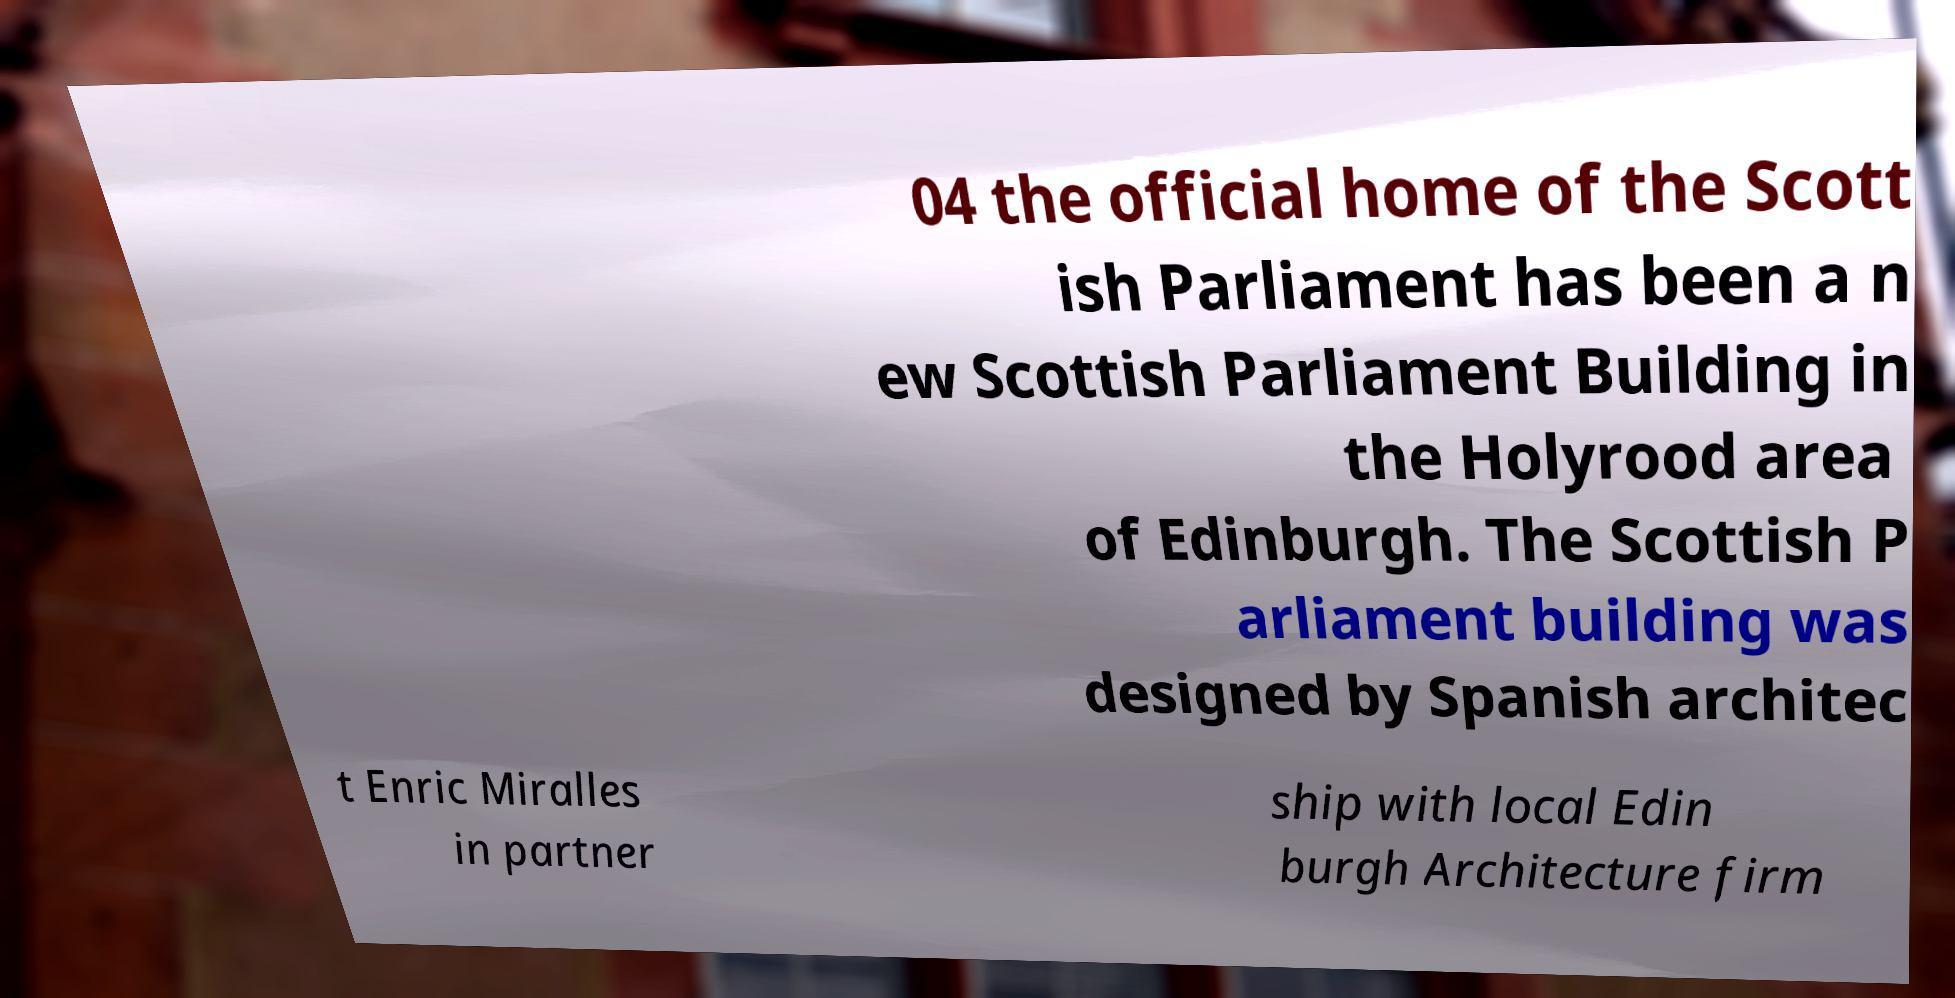There's text embedded in this image that I need extracted. Can you transcribe it verbatim? 04 the official home of the Scott ish Parliament has been a n ew Scottish Parliament Building in the Holyrood area of Edinburgh. The Scottish P arliament building was designed by Spanish architec t Enric Miralles in partner ship with local Edin burgh Architecture firm 